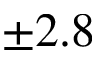Convert formula to latex. <formula><loc_0><loc_0><loc_500><loc_500>\pm 2 . 8</formula> 